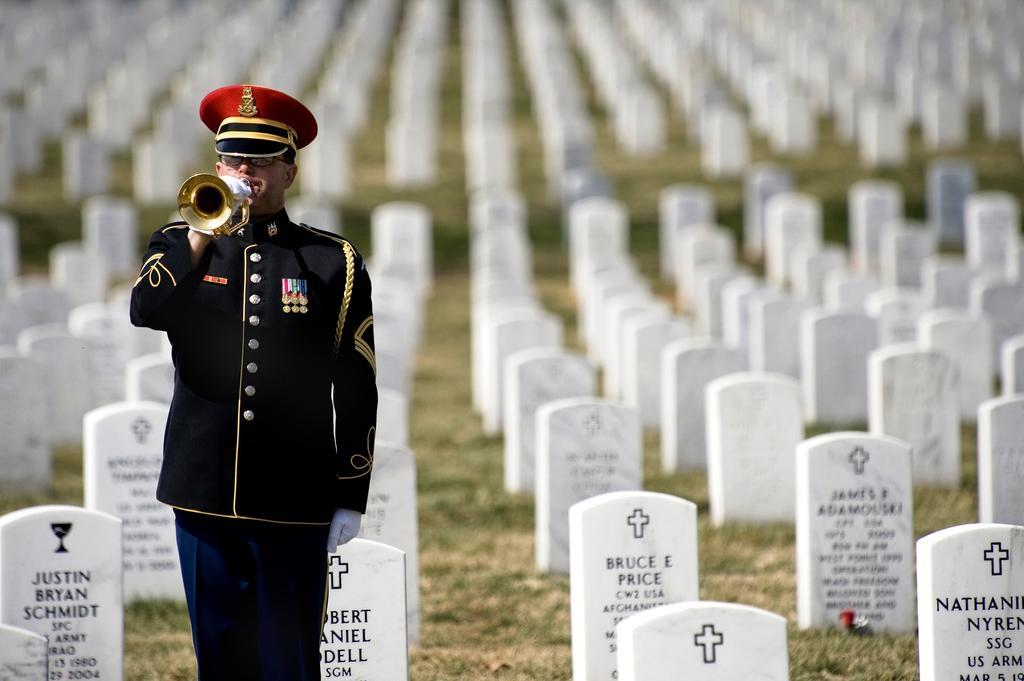Could you give a brief overview of what you see in this image? In this image I can see a person wearing black and red colored dress is standing and holding a musical instrument in his hand. In the background I can see the cemetery and number of tombstones which are white in color on the ground. 